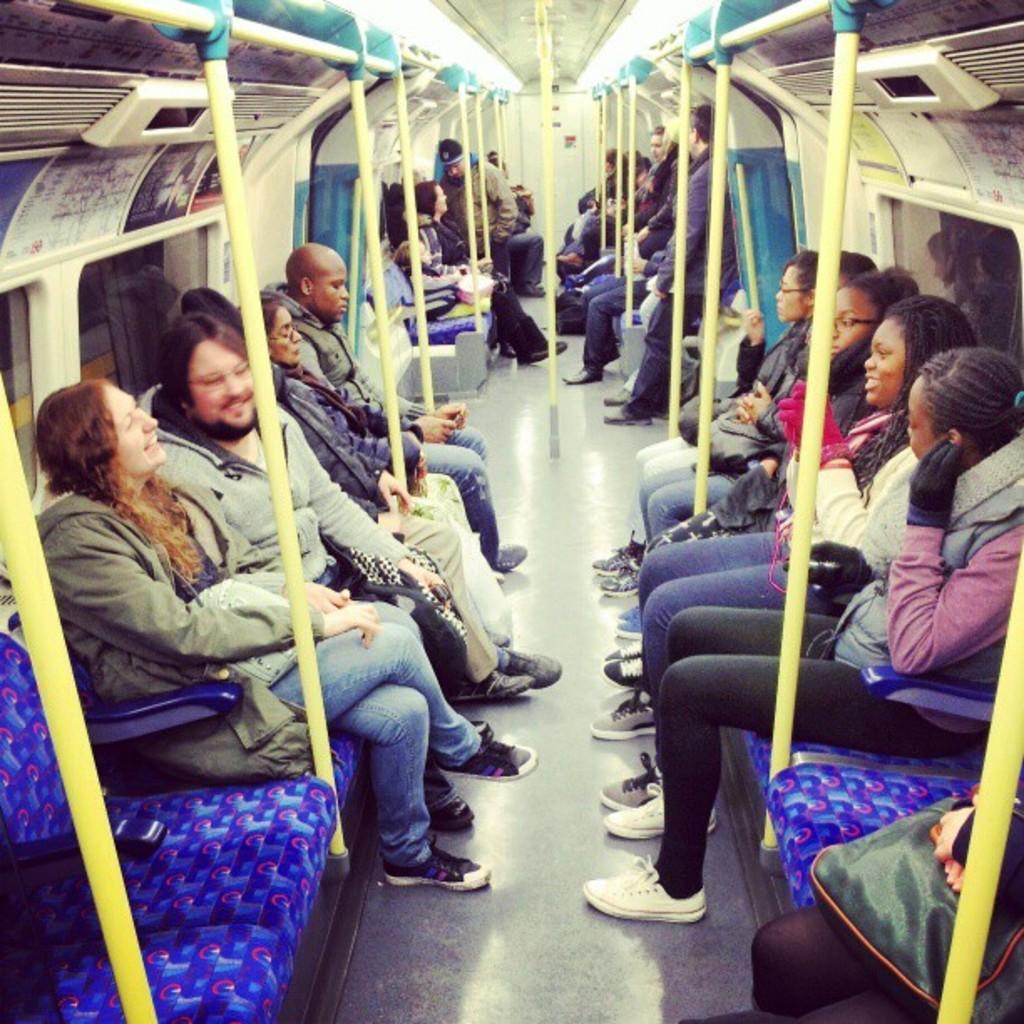In one or two sentences, can you explain what this image depicts? In this image there are group of persons sitting and standing. On the left side there are persons sitting and in the front there is a woman sitting and smiling. In the center there are poles. On the left side in the front there is a blue colour empty seat. 